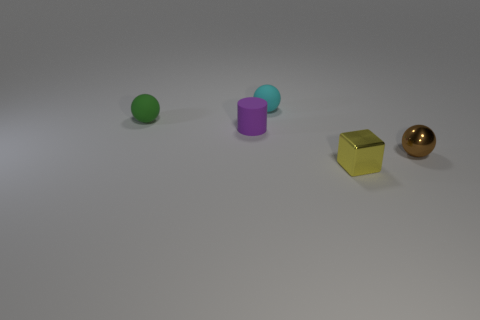Add 4 tiny rubber objects. How many objects exist? 9 Subtract all cubes. How many objects are left? 4 Subtract all small brown metal objects. Subtract all brown balls. How many objects are left? 3 Add 2 green rubber balls. How many green rubber balls are left? 3 Add 1 gray rubber blocks. How many gray rubber blocks exist? 1 Subtract 0 red cylinders. How many objects are left? 5 